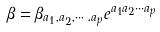<formula> <loc_0><loc_0><loc_500><loc_500>\beta = \beta _ { a _ { 1 } , a _ { 2 } , \cdots . a _ { p } } e ^ { a _ { 1 } a _ { 2 } \cdots a _ { p } }</formula> 